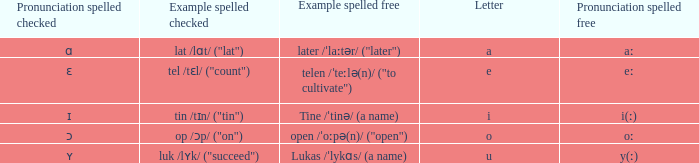What is Pronunciation Spelled Checked, when Example Spelled Checked is "tin /tɪn/ ("tin")" Ɪ. 